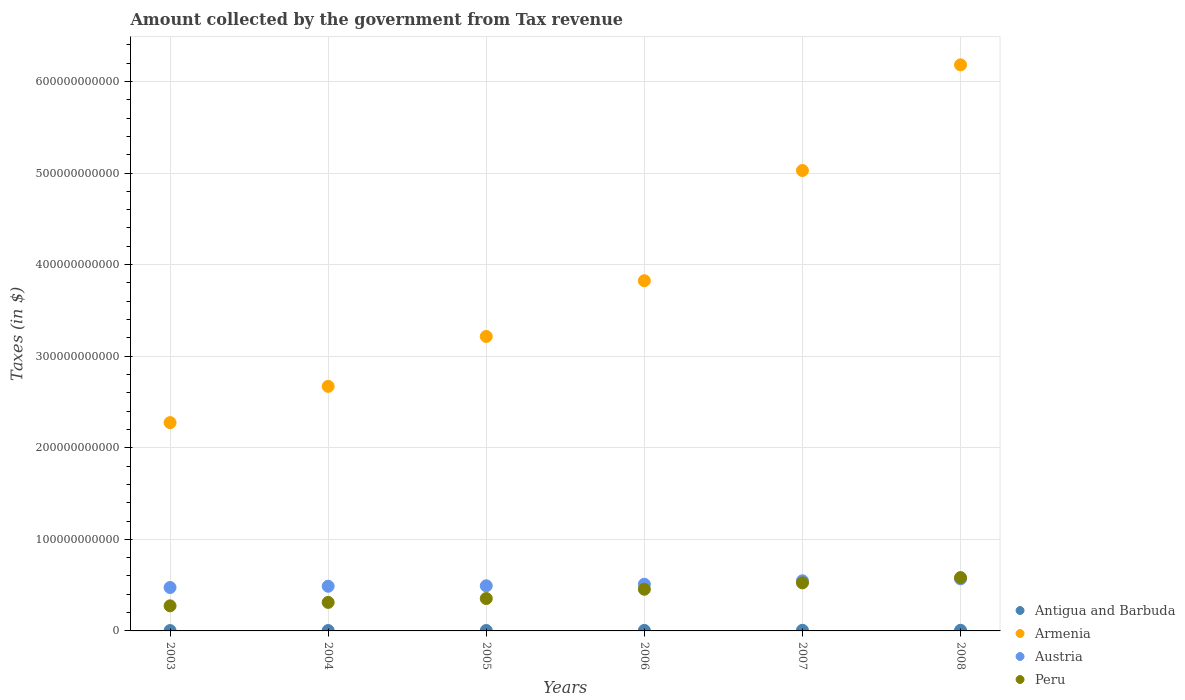How many different coloured dotlines are there?
Give a very brief answer. 4. What is the amount collected by the government from tax revenue in Peru in 2007?
Offer a terse response. 5.25e+1. Across all years, what is the maximum amount collected by the government from tax revenue in Austria?
Offer a terse response. 5.69e+1. Across all years, what is the minimum amount collected by the government from tax revenue in Peru?
Your answer should be compact. 2.74e+1. What is the total amount collected by the government from tax revenue in Austria in the graph?
Provide a short and direct response. 3.08e+11. What is the difference between the amount collected by the government from tax revenue in Armenia in 2004 and that in 2007?
Provide a succinct answer. -2.36e+11. What is the difference between the amount collected by the government from tax revenue in Peru in 2006 and the amount collected by the government from tax revenue in Antigua and Barbuda in 2004?
Your response must be concise. 4.51e+1. What is the average amount collected by the government from tax revenue in Antigua and Barbuda per year?
Offer a terse response. 5.36e+08. In the year 2005, what is the difference between the amount collected by the government from tax revenue in Austria and amount collected by the government from tax revenue in Armenia?
Give a very brief answer. -2.72e+11. What is the ratio of the amount collected by the government from tax revenue in Austria in 2003 to that in 2007?
Offer a terse response. 0.87. What is the difference between the highest and the second highest amount collected by the government from tax revenue in Antigua and Barbuda?
Your answer should be compact. 1.50e+06. What is the difference between the highest and the lowest amount collected by the government from tax revenue in Antigua and Barbuda?
Your answer should be compact. 3.09e+08. Is the sum of the amount collected by the government from tax revenue in Antigua and Barbuda in 2004 and 2005 greater than the maximum amount collected by the government from tax revenue in Peru across all years?
Offer a very short reply. No. Does the amount collected by the government from tax revenue in Antigua and Barbuda monotonically increase over the years?
Your answer should be compact. Yes. Is the amount collected by the government from tax revenue in Peru strictly greater than the amount collected by the government from tax revenue in Antigua and Barbuda over the years?
Make the answer very short. Yes. What is the difference between two consecutive major ticks on the Y-axis?
Keep it short and to the point. 1.00e+11. Are the values on the major ticks of Y-axis written in scientific E-notation?
Ensure brevity in your answer.  No. Does the graph contain any zero values?
Keep it short and to the point. No. Does the graph contain grids?
Give a very brief answer. Yes. How many legend labels are there?
Keep it short and to the point. 4. How are the legend labels stacked?
Your answer should be very brief. Vertical. What is the title of the graph?
Provide a succinct answer. Amount collected by the government from Tax revenue. What is the label or title of the X-axis?
Provide a short and direct response. Years. What is the label or title of the Y-axis?
Make the answer very short. Taxes (in $). What is the Taxes (in $) in Antigua and Barbuda in 2003?
Offer a very short reply. 3.83e+08. What is the Taxes (in $) of Armenia in 2003?
Provide a short and direct response. 2.27e+11. What is the Taxes (in $) in Austria in 2003?
Your response must be concise. 4.74e+1. What is the Taxes (in $) in Peru in 2003?
Keep it short and to the point. 2.74e+1. What is the Taxes (in $) of Antigua and Barbuda in 2004?
Give a very brief answer. 4.27e+08. What is the Taxes (in $) in Armenia in 2004?
Ensure brevity in your answer.  2.67e+11. What is the Taxes (in $) in Austria in 2004?
Make the answer very short. 4.88e+1. What is the Taxes (in $) of Peru in 2004?
Give a very brief answer. 3.11e+1. What is the Taxes (in $) in Antigua and Barbuda in 2005?
Keep it short and to the point. 4.55e+08. What is the Taxes (in $) of Armenia in 2005?
Make the answer very short. 3.22e+11. What is the Taxes (in $) of Austria in 2005?
Offer a very short reply. 4.93e+1. What is the Taxes (in $) of Peru in 2005?
Give a very brief answer. 3.54e+1. What is the Taxes (in $) in Antigua and Barbuda in 2006?
Give a very brief answer. 5.68e+08. What is the Taxes (in $) of Armenia in 2006?
Offer a terse response. 3.82e+11. What is the Taxes (in $) in Austria in 2006?
Ensure brevity in your answer.  5.10e+1. What is the Taxes (in $) in Peru in 2006?
Your answer should be very brief. 4.55e+1. What is the Taxes (in $) of Antigua and Barbuda in 2007?
Make the answer very short. 6.91e+08. What is the Taxes (in $) of Armenia in 2007?
Provide a short and direct response. 5.03e+11. What is the Taxes (in $) of Austria in 2007?
Your answer should be compact. 5.47e+1. What is the Taxes (in $) in Peru in 2007?
Make the answer very short. 5.25e+1. What is the Taxes (in $) of Antigua and Barbuda in 2008?
Ensure brevity in your answer.  6.92e+08. What is the Taxes (in $) in Armenia in 2008?
Offer a terse response. 6.18e+11. What is the Taxes (in $) of Austria in 2008?
Provide a succinct answer. 5.69e+1. What is the Taxes (in $) of Peru in 2008?
Offer a very short reply. 5.82e+1. Across all years, what is the maximum Taxes (in $) of Antigua and Barbuda?
Give a very brief answer. 6.92e+08. Across all years, what is the maximum Taxes (in $) in Armenia?
Provide a short and direct response. 6.18e+11. Across all years, what is the maximum Taxes (in $) in Austria?
Provide a succinct answer. 5.69e+1. Across all years, what is the maximum Taxes (in $) of Peru?
Provide a short and direct response. 5.82e+1. Across all years, what is the minimum Taxes (in $) of Antigua and Barbuda?
Your answer should be very brief. 3.83e+08. Across all years, what is the minimum Taxes (in $) of Armenia?
Offer a terse response. 2.27e+11. Across all years, what is the minimum Taxes (in $) of Austria?
Your response must be concise. 4.74e+1. Across all years, what is the minimum Taxes (in $) of Peru?
Keep it short and to the point. 2.74e+1. What is the total Taxes (in $) of Antigua and Barbuda in the graph?
Offer a very short reply. 3.22e+09. What is the total Taxes (in $) in Armenia in the graph?
Give a very brief answer. 2.32e+12. What is the total Taxes (in $) in Austria in the graph?
Your answer should be very brief. 3.08e+11. What is the total Taxes (in $) in Peru in the graph?
Provide a short and direct response. 2.50e+11. What is the difference between the Taxes (in $) in Antigua and Barbuda in 2003 and that in 2004?
Offer a terse response. -4.40e+07. What is the difference between the Taxes (in $) of Armenia in 2003 and that in 2004?
Provide a succinct answer. -3.96e+1. What is the difference between the Taxes (in $) in Austria in 2003 and that in 2004?
Keep it short and to the point. -1.38e+09. What is the difference between the Taxes (in $) in Peru in 2003 and that in 2004?
Your answer should be compact. -3.74e+09. What is the difference between the Taxes (in $) in Antigua and Barbuda in 2003 and that in 2005?
Your response must be concise. -7.18e+07. What is the difference between the Taxes (in $) in Armenia in 2003 and that in 2005?
Offer a terse response. -9.41e+1. What is the difference between the Taxes (in $) of Austria in 2003 and that in 2005?
Ensure brevity in your answer.  -1.86e+09. What is the difference between the Taxes (in $) in Peru in 2003 and that in 2005?
Offer a very short reply. -7.96e+09. What is the difference between the Taxes (in $) of Antigua and Barbuda in 2003 and that in 2006?
Provide a short and direct response. -1.84e+08. What is the difference between the Taxes (in $) in Armenia in 2003 and that in 2006?
Keep it short and to the point. -1.55e+11. What is the difference between the Taxes (in $) in Austria in 2003 and that in 2006?
Offer a terse response. -3.57e+09. What is the difference between the Taxes (in $) in Peru in 2003 and that in 2006?
Keep it short and to the point. -1.81e+1. What is the difference between the Taxes (in $) in Antigua and Barbuda in 2003 and that in 2007?
Keep it short and to the point. -3.08e+08. What is the difference between the Taxes (in $) in Armenia in 2003 and that in 2007?
Offer a very short reply. -2.75e+11. What is the difference between the Taxes (in $) in Austria in 2003 and that in 2007?
Provide a short and direct response. -7.33e+09. What is the difference between the Taxes (in $) of Peru in 2003 and that in 2007?
Your answer should be very brief. -2.50e+1. What is the difference between the Taxes (in $) in Antigua and Barbuda in 2003 and that in 2008?
Make the answer very short. -3.09e+08. What is the difference between the Taxes (in $) of Armenia in 2003 and that in 2008?
Offer a terse response. -3.91e+11. What is the difference between the Taxes (in $) in Austria in 2003 and that in 2008?
Provide a short and direct response. -9.44e+09. What is the difference between the Taxes (in $) of Peru in 2003 and that in 2008?
Provide a succinct answer. -3.08e+1. What is the difference between the Taxes (in $) of Antigua and Barbuda in 2004 and that in 2005?
Provide a succinct answer. -2.78e+07. What is the difference between the Taxes (in $) in Armenia in 2004 and that in 2005?
Your response must be concise. -5.45e+1. What is the difference between the Taxes (in $) in Austria in 2004 and that in 2005?
Make the answer very short. -4.75e+08. What is the difference between the Taxes (in $) in Peru in 2004 and that in 2005?
Offer a very short reply. -4.22e+09. What is the difference between the Taxes (in $) of Antigua and Barbuda in 2004 and that in 2006?
Ensure brevity in your answer.  -1.40e+08. What is the difference between the Taxes (in $) in Armenia in 2004 and that in 2006?
Your response must be concise. -1.15e+11. What is the difference between the Taxes (in $) in Austria in 2004 and that in 2006?
Your response must be concise. -2.19e+09. What is the difference between the Taxes (in $) of Peru in 2004 and that in 2006?
Provide a short and direct response. -1.43e+1. What is the difference between the Taxes (in $) in Antigua and Barbuda in 2004 and that in 2007?
Ensure brevity in your answer.  -2.64e+08. What is the difference between the Taxes (in $) of Armenia in 2004 and that in 2007?
Keep it short and to the point. -2.36e+11. What is the difference between the Taxes (in $) in Austria in 2004 and that in 2007?
Keep it short and to the point. -5.95e+09. What is the difference between the Taxes (in $) in Peru in 2004 and that in 2007?
Make the answer very short. -2.13e+1. What is the difference between the Taxes (in $) in Antigua and Barbuda in 2004 and that in 2008?
Provide a succinct answer. -2.65e+08. What is the difference between the Taxes (in $) in Armenia in 2004 and that in 2008?
Ensure brevity in your answer.  -3.51e+11. What is the difference between the Taxes (in $) in Austria in 2004 and that in 2008?
Your answer should be compact. -8.06e+09. What is the difference between the Taxes (in $) in Peru in 2004 and that in 2008?
Offer a very short reply. -2.71e+1. What is the difference between the Taxes (in $) of Antigua and Barbuda in 2005 and that in 2006?
Offer a terse response. -1.13e+08. What is the difference between the Taxes (in $) in Armenia in 2005 and that in 2006?
Offer a very short reply. -6.09e+1. What is the difference between the Taxes (in $) of Austria in 2005 and that in 2006?
Ensure brevity in your answer.  -1.71e+09. What is the difference between the Taxes (in $) of Peru in 2005 and that in 2006?
Make the answer very short. -1.01e+1. What is the difference between the Taxes (in $) of Antigua and Barbuda in 2005 and that in 2007?
Offer a terse response. -2.36e+08. What is the difference between the Taxes (in $) of Armenia in 2005 and that in 2007?
Keep it short and to the point. -1.81e+11. What is the difference between the Taxes (in $) of Austria in 2005 and that in 2007?
Provide a short and direct response. -5.47e+09. What is the difference between the Taxes (in $) of Peru in 2005 and that in 2007?
Make the answer very short. -1.71e+1. What is the difference between the Taxes (in $) of Antigua and Barbuda in 2005 and that in 2008?
Provide a short and direct response. -2.37e+08. What is the difference between the Taxes (in $) of Armenia in 2005 and that in 2008?
Make the answer very short. -2.97e+11. What is the difference between the Taxes (in $) of Austria in 2005 and that in 2008?
Ensure brevity in your answer.  -7.59e+09. What is the difference between the Taxes (in $) of Peru in 2005 and that in 2008?
Keep it short and to the point. -2.29e+1. What is the difference between the Taxes (in $) of Antigua and Barbuda in 2006 and that in 2007?
Your response must be concise. -1.23e+08. What is the difference between the Taxes (in $) in Armenia in 2006 and that in 2007?
Your answer should be compact. -1.20e+11. What is the difference between the Taxes (in $) in Austria in 2006 and that in 2007?
Ensure brevity in your answer.  -3.76e+09. What is the difference between the Taxes (in $) in Peru in 2006 and that in 2007?
Ensure brevity in your answer.  -6.97e+09. What is the difference between the Taxes (in $) in Antigua and Barbuda in 2006 and that in 2008?
Offer a very short reply. -1.25e+08. What is the difference between the Taxes (in $) in Armenia in 2006 and that in 2008?
Give a very brief answer. -2.36e+11. What is the difference between the Taxes (in $) in Austria in 2006 and that in 2008?
Provide a succinct answer. -5.88e+09. What is the difference between the Taxes (in $) in Peru in 2006 and that in 2008?
Your answer should be very brief. -1.28e+1. What is the difference between the Taxes (in $) in Antigua and Barbuda in 2007 and that in 2008?
Ensure brevity in your answer.  -1.50e+06. What is the difference between the Taxes (in $) of Armenia in 2007 and that in 2008?
Make the answer very short. -1.15e+11. What is the difference between the Taxes (in $) in Austria in 2007 and that in 2008?
Give a very brief answer. -2.12e+09. What is the difference between the Taxes (in $) of Peru in 2007 and that in 2008?
Your answer should be very brief. -5.79e+09. What is the difference between the Taxes (in $) of Antigua and Barbuda in 2003 and the Taxes (in $) of Armenia in 2004?
Provide a short and direct response. -2.67e+11. What is the difference between the Taxes (in $) of Antigua and Barbuda in 2003 and the Taxes (in $) of Austria in 2004?
Your answer should be compact. -4.84e+1. What is the difference between the Taxes (in $) in Antigua and Barbuda in 2003 and the Taxes (in $) in Peru in 2004?
Offer a terse response. -3.08e+1. What is the difference between the Taxes (in $) in Armenia in 2003 and the Taxes (in $) in Austria in 2004?
Offer a very short reply. 1.79e+11. What is the difference between the Taxes (in $) of Armenia in 2003 and the Taxes (in $) of Peru in 2004?
Give a very brief answer. 1.96e+11. What is the difference between the Taxes (in $) in Austria in 2003 and the Taxes (in $) in Peru in 2004?
Keep it short and to the point. 1.63e+1. What is the difference between the Taxes (in $) of Antigua and Barbuda in 2003 and the Taxes (in $) of Armenia in 2005?
Provide a short and direct response. -3.21e+11. What is the difference between the Taxes (in $) of Antigua and Barbuda in 2003 and the Taxes (in $) of Austria in 2005?
Your answer should be compact. -4.89e+1. What is the difference between the Taxes (in $) in Antigua and Barbuda in 2003 and the Taxes (in $) in Peru in 2005?
Your answer should be compact. -3.50e+1. What is the difference between the Taxes (in $) of Armenia in 2003 and the Taxes (in $) of Austria in 2005?
Ensure brevity in your answer.  1.78e+11. What is the difference between the Taxes (in $) in Armenia in 2003 and the Taxes (in $) in Peru in 2005?
Your response must be concise. 1.92e+11. What is the difference between the Taxes (in $) of Austria in 2003 and the Taxes (in $) of Peru in 2005?
Offer a very short reply. 1.20e+1. What is the difference between the Taxes (in $) of Antigua and Barbuda in 2003 and the Taxes (in $) of Armenia in 2006?
Offer a terse response. -3.82e+11. What is the difference between the Taxes (in $) in Antigua and Barbuda in 2003 and the Taxes (in $) in Austria in 2006?
Your answer should be compact. -5.06e+1. What is the difference between the Taxes (in $) in Antigua and Barbuda in 2003 and the Taxes (in $) in Peru in 2006?
Offer a terse response. -4.51e+1. What is the difference between the Taxes (in $) of Armenia in 2003 and the Taxes (in $) of Austria in 2006?
Your answer should be very brief. 1.76e+11. What is the difference between the Taxes (in $) in Armenia in 2003 and the Taxes (in $) in Peru in 2006?
Your answer should be compact. 1.82e+11. What is the difference between the Taxes (in $) of Austria in 2003 and the Taxes (in $) of Peru in 2006?
Offer a very short reply. 1.93e+09. What is the difference between the Taxes (in $) of Antigua and Barbuda in 2003 and the Taxes (in $) of Armenia in 2007?
Your response must be concise. -5.02e+11. What is the difference between the Taxes (in $) in Antigua and Barbuda in 2003 and the Taxes (in $) in Austria in 2007?
Make the answer very short. -5.44e+1. What is the difference between the Taxes (in $) of Antigua and Barbuda in 2003 and the Taxes (in $) of Peru in 2007?
Offer a very short reply. -5.21e+1. What is the difference between the Taxes (in $) of Armenia in 2003 and the Taxes (in $) of Austria in 2007?
Offer a terse response. 1.73e+11. What is the difference between the Taxes (in $) in Armenia in 2003 and the Taxes (in $) in Peru in 2007?
Provide a succinct answer. 1.75e+11. What is the difference between the Taxes (in $) in Austria in 2003 and the Taxes (in $) in Peru in 2007?
Keep it short and to the point. -5.04e+09. What is the difference between the Taxes (in $) of Antigua and Barbuda in 2003 and the Taxes (in $) of Armenia in 2008?
Provide a short and direct response. -6.18e+11. What is the difference between the Taxes (in $) of Antigua and Barbuda in 2003 and the Taxes (in $) of Austria in 2008?
Your response must be concise. -5.65e+1. What is the difference between the Taxes (in $) in Antigua and Barbuda in 2003 and the Taxes (in $) in Peru in 2008?
Your response must be concise. -5.79e+1. What is the difference between the Taxes (in $) in Armenia in 2003 and the Taxes (in $) in Austria in 2008?
Make the answer very short. 1.71e+11. What is the difference between the Taxes (in $) of Armenia in 2003 and the Taxes (in $) of Peru in 2008?
Your answer should be compact. 1.69e+11. What is the difference between the Taxes (in $) of Austria in 2003 and the Taxes (in $) of Peru in 2008?
Your response must be concise. -1.08e+1. What is the difference between the Taxes (in $) in Antigua and Barbuda in 2004 and the Taxes (in $) in Armenia in 2005?
Give a very brief answer. -3.21e+11. What is the difference between the Taxes (in $) of Antigua and Barbuda in 2004 and the Taxes (in $) of Austria in 2005?
Keep it short and to the point. -4.88e+1. What is the difference between the Taxes (in $) in Antigua and Barbuda in 2004 and the Taxes (in $) in Peru in 2005?
Provide a short and direct response. -3.49e+1. What is the difference between the Taxes (in $) in Armenia in 2004 and the Taxes (in $) in Austria in 2005?
Your response must be concise. 2.18e+11. What is the difference between the Taxes (in $) of Armenia in 2004 and the Taxes (in $) of Peru in 2005?
Provide a succinct answer. 2.32e+11. What is the difference between the Taxes (in $) in Austria in 2004 and the Taxes (in $) in Peru in 2005?
Keep it short and to the point. 1.34e+1. What is the difference between the Taxes (in $) in Antigua and Barbuda in 2004 and the Taxes (in $) in Armenia in 2006?
Your answer should be very brief. -3.82e+11. What is the difference between the Taxes (in $) of Antigua and Barbuda in 2004 and the Taxes (in $) of Austria in 2006?
Ensure brevity in your answer.  -5.06e+1. What is the difference between the Taxes (in $) of Antigua and Barbuda in 2004 and the Taxes (in $) of Peru in 2006?
Provide a succinct answer. -4.51e+1. What is the difference between the Taxes (in $) of Armenia in 2004 and the Taxes (in $) of Austria in 2006?
Make the answer very short. 2.16e+11. What is the difference between the Taxes (in $) of Armenia in 2004 and the Taxes (in $) of Peru in 2006?
Ensure brevity in your answer.  2.22e+11. What is the difference between the Taxes (in $) in Austria in 2004 and the Taxes (in $) in Peru in 2006?
Provide a short and direct response. 3.31e+09. What is the difference between the Taxes (in $) of Antigua and Barbuda in 2004 and the Taxes (in $) of Armenia in 2007?
Ensure brevity in your answer.  -5.02e+11. What is the difference between the Taxes (in $) in Antigua and Barbuda in 2004 and the Taxes (in $) in Austria in 2007?
Provide a short and direct response. -5.43e+1. What is the difference between the Taxes (in $) of Antigua and Barbuda in 2004 and the Taxes (in $) of Peru in 2007?
Offer a very short reply. -5.20e+1. What is the difference between the Taxes (in $) in Armenia in 2004 and the Taxes (in $) in Austria in 2007?
Provide a short and direct response. 2.12e+11. What is the difference between the Taxes (in $) in Armenia in 2004 and the Taxes (in $) in Peru in 2007?
Offer a terse response. 2.15e+11. What is the difference between the Taxes (in $) in Austria in 2004 and the Taxes (in $) in Peru in 2007?
Your answer should be compact. -3.66e+09. What is the difference between the Taxes (in $) of Antigua and Barbuda in 2004 and the Taxes (in $) of Armenia in 2008?
Offer a terse response. -6.18e+11. What is the difference between the Taxes (in $) in Antigua and Barbuda in 2004 and the Taxes (in $) in Austria in 2008?
Your response must be concise. -5.64e+1. What is the difference between the Taxes (in $) of Antigua and Barbuda in 2004 and the Taxes (in $) of Peru in 2008?
Ensure brevity in your answer.  -5.78e+1. What is the difference between the Taxes (in $) in Armenia in 2004 and the Taxes (in $) in Austria in 2008?
Your answer should be compact. 2.10e+11. What is the difference between the Taxes (in $) in Armenia in 2004 and the Taxes (in $) in Peru in 2008?
Provide a succinct answer. 2.09e+11. What is the difference between the Taxes (in $) in Austria in 2004 and the Taxes (in $) in Peru in 2008?
Ensure brevity in your answer.  -9.45e+09. What is the difference between the Taxes (in $) in Antigua and Barbuda in 2005 and the Taxes (in $) in Armenia in 2006?
Offer a very short reply. -3.82e+11. What is the difference between the Taxes (in $) of Antigua and Barbuda in 2005 and the Taxes (in $) of Austria in 2006?
Offer a very short reply. -5.05e+1. What is the difference between the Taxes (in $) of Antigua and Barbuda in 2005 and the Taxes (in $) of Peru in 2006?
Give a very brief answer. -4.50e+1. What is the difference between the Taxes (in $) in Armenia in 2005 and the Taxes (in $) in Austria in 2006?
Keep it short and to the point. 2.71e+11. What is the difference between the Taxes (in $) of Armenia in 2005 and the Taxes (in $) of Peru in 2006?
Provide a short and direct response. 2.76e+11. What is the difference between the Taxes (in $) of Austria in 2005 and the Taxes (in $) of Peru in 2006?
Provide a short and direct response. 3.78e+09. What is the difference between the Taxes (in $) in Antigua and Barbuda in 2005 and the Taxes (in $) in Armenia in 2007?
Ensure brevity in your answer.  -5.02e+11. What is the difference between the Taxes (in $) in Antigua and Barbuda in 2005 and the Taxes (in $) in Austria in 2007?
Offer a very short reply. -5.43e+1. What is the difference between the Taxes (in $) in Antigua and Barbuda in 2005 and the Taxes (in $) in Peru in 2007?
Your answer should be compact. -5.20e+1. What is the difference between the Taxes (in $) of Armenia in 2005 and the Taxes (in $) of Austria in 2007?
Give a very brief answer. 2.67e+11. What is the difference between the Taxes (in $) in Armenia in 2005 and the Taxes (in $) in Peru in 2007?
Ensure brevity in your answer.  2.69e+11. What is the difference between the Taxes (in $) in Austria in 2005 and the Taxes (in $) in Peru in 2007?
Make the answer very short. -3.19e+09. What is the difference between the Taxes (in $) of Antigua and Barbuda in 2005 and the Taxes (in $) of Armenia in 2008?
Your response must be concise. -6.18e+11. What is the difference between the Taxes (in $) in Antigua and Barbuda in 2005 and the Taxes (in $) in Austria in 2008?
Offer a very short reply. -5.64e+1. What is the difference between the Taxes (in $) of Antigua and Barbuda in 2005 and the Taxes (in $) of Peru in 2008?
Your answer should be compact. -5.78e+1. What is the difference between the Taxes (in $) in Armenia in 2005 and the Taxes (in $) in Austria in 2008?
Provide a short and direct response. 2.65e+11. What is the difference between the Taxes (in $) in Armenia in 2005 and the Taxes (in $) in Peru in 2008?
Your answer should be compact. 2.63e+11. What is the difference between the Taxes (in $) of Austria in 2005 and the Taxes (in $) of Peru in 2008?
Make the answer very short. -8.97e+09. What is the difference between the Taxes (in $) in Antigua and Barbuda in 2006 and the Taxes (in $) in Armenia in 2007?
Your answer should be compact. -5.02e+11. What is the difference between the Taxes (in $) in Antigua and Barbuda in 2006 and the Taxes (in $) in Austria in 2007?
Offer a terse response. -5.42e+1. What is the difference between the Taxes (in $) in Antigua and Barbuda in 2006 and the Taxes (in $) in Peru in 2007?
Your answer should be very brief. -5.19e+1. What is the difference between the Taxes (in $) of Armenia in 2006 and the Taxes (in $) of Austria in 2007?
Make the answer very short. 3.28e+11. What is the difference between the Taxes (in $) in Armenia in 2006 and the Taxes (in $) in Peru in 2007?
Give a very brief answer. 3.30e+11. What is the difference between the Taxes (in $) in Austria in 2006 and the Taxes (in $) in Peru in 2007?
Your response must be concise. -1.48e+09. What is the difference between the Taxes (in $) in Antigua and Barbuda in 2006 and the Taxes (in $) in Armenia in 2008?
Offer a terse response. -6.18e+11. What is the difference between the Taxes (in $) in Antigua and Barbuda in 2006 and the Taxes (in $) in Austria in 2008?
Offer a terse response. -5.63e+1. What is the difference between the Taxes (in $) of Antigua and Barbuda in 2006 and the Taxes (in $) of Peru in 2008?
Keep it short and to the point. -5.77e+1. What is the difference between the Taxes (in $) in Armenia in 2006 and the Taxes (in $) in Austria in 2008?
Your response must be concise. 3.26e+11. What is the difference between the Taxes (in $) of Armenia in 2006 and the Taxes (in $) of Peru in 2008?
Provide a short and direct response. 3.24e+11. What is the difference between the Taxes (in $) of Austria in 2006 and the Taxes (in $) of Peru in 2008?
Your answer should be very brief. -7.26e+09. What is the difference between the Taxes (in $) in Antigua and Barbuda in 2007 and the Taxes (in $) in Armenia in 2008?
Provide a succinct answer. -6.17e+11. What is the difference between the Taxes (in $) of Antigua and Barbuda in 2007 and the Taxes (in $) of Austria in 2008?
Offer a very short reply. -5.62e+1. What is the difference between the Taxes (in $) in Antigua and Barbuda in 2007 and the Taxes (in $) in Peru in 2008?
Offer a terse response. -5.76e+1. What is the difference between the Taxes (in $) in Armenia in 2007 and the Taxes (in $) in Austria in 2008?
Your response must be concise. 4.46e+11. What is the difference between the Taxes (in $) of Armenia in 2007 and the Taxes (in $) of Peru in 2008?
Your answer should be very brief. 4.44e+11. What is the difference between the Taxes (in $) of Austria in 2007 and the Taxes (in $) of Peru in 2008?
Your response must be concise. -3.50e+09. What is the average Taxes (in $) of Antigua and Barbuda per year?
Make the answer very short. 5.36e+08. What is the average Taxes (in $) in Armenia per year?
Offer a terse response. 3.87e+11. What is the average Taxes (in $) of Austria per year?
Make the answer very short. 5.13e+1. What is the average Taxes (in $) in Peru per year?
Give a very brief answer. 4.17e+1. In the year 2003, what is the difference between the Taxes (in $) of Antigua and Barbuda and Taxes (in $) of Armenia?
Offer a terse response. -2.27e+11. In the year 2003, what is the difference between the Taxes (in $) of Antigua and Barbuda and Taxes (in $) of Austria?
Offer a very short reply. -4.70e+1. In the year 2003, what is the difference between the Taxes (in $) of Antigua and Barbuda and Taxes (in $) of Peru?
Keep it short and to the point. -2.70e+1. In the year 2003, what is the difference between the Taxes (in $) of Armenia and Taxes (in $) of Austria?
Offer a terse response. 1.80e+11. In the year 2003, what is the difference between the Taxes (in $) of Armenia and Taxes (in $) of Peru?
Your answer should be very brief. 2.00e+11. In the year 2003, what is the difference between the Taxes (in $) in Austria and Taxes (in $) in Peru?
Provide a succinct answer. 2.00e+1. In the year 2004, what is the difference between the Taxes (in $) in Antigua and Barbuda and Taxes (in $) in Armenia?
Your answer should be very brief. -2.67e+11. In the year 2004, what is the difference between the Taxes (in $) in Antigua and Barbuda and Taxes (in $) in Austria?
Give a very brief answer. -4.84e+1. In the year 2004, what is the difference between the Taxes (in $) of Antigua and Barbuda and Taxes (in $) of Peru?
Your answer should be compact. -3.07e+1. In the year 2004, what is the difference between the Taxes (in $) in Armenia and Taxes (in $) in Austria?
Make the answer very short. 2.18e+11. In the year 2004, what is the difference between the Taxes (in $) of Armenia and Taxes (in $) of Peru?
Your answer should be compact. 2.36e+11. In the year 2004, what is the difference between the Taxes (in $) of Austria and Taxes (in $) of Peru?
Your response must be concise. 1.76e+1. In the year 2005, what is the difference between the Taxes (in $) of Antigua and Barbuda and Taxes (in $) of Armenia?
Offer a terse response. -3.21e+11. In the year 2005, what is the difference between the Taxes (in $) of Antigua and Barbuda and Taxes (in $) of Austria?
Ensure brevity in your answer.  -4.88e+1. In the year 2005, what is the difference between the Taxes (in $) of Antigua and Barbuda and Taxes (in $) of Peru?
Your answer should be very brief. -3.49e+1. In the year 2005, what is the difference between the Taxes (in $) in Armenia and Taxes (in $) in Austria?
Make the answer very short. 2.72e+11. In the year 2005, what is the difference between the Taxes (in $) in Armenia and Taxes (in $) in Peru?
Your answer should be very brief. 2.86e+11. In the year 2005, what is the difference between the Taxes (in $) in Austria and Taxes (in $) in Peru?
Provide a short and direct response. 1.39e+1. In the year 2006, what is the difference between the Taxes (in $) in Antigua and Barbuda and Taxes (in $) in Armenia?
Offer a very short reply. -3.82e+11. In the year 2006, what is the difference between the Taxes (in $) of Antigua and Barbuda and Taxes (in $) of Austria?
Your response must be concise. -5.04e+1. In the year 2006, what is the difference between the Taxes (in $) in Antigua and Barbuda and Taxes (in $) in Peru?
Provide a succinct answer. -4.49e+1. In the year 2006, what is the difference between the Taxes (in $) in Armenia and Taxes (in $) in Austria?
Your answer should be very brief. 3.31e+11. In the year 2006, what is the difference between the Taxes (in $) in Armenia and Taxes (in $) in Peru?
Offer a very short reply. 3.37e+11. In the year 2006, what is the difference between the Taxes (in $) in Austria and Taxes (in $) in Peru?
Make the answer very short. 5.49e+09. In the year 2007, what is the difference between the Taxes (in $) in Antigua and Barbuda and Taxes (in $) in Armenia?
Provide a short and direct response. -5.02e+11. In the year 2007, what is the difference between the Taxes (in $) of Antigua and Barbuda and Taxes (in $) of Austria?
Provide a succinct answer. -5.40e+1. In the year 2007, what is the difference between the Taxes (in $) of Antigua and Barbuda and Taxes (in $) of Peru?
Your response must be concise. -5.18e+1. In the year 2007, what is the difference between the Taxes (in $) of Armenia and Taxes (in $) of Austria?
Offer a very short reply. 4.48e+11. In the year 2007, what is the difference between the Taxes (in $) of Armenia and Taxes (in $) of Peru?
Provide a succinct answer. 4.50e+11. In the year 2007, what is the difference between the Taxes (in $) of Austria and Taxes (in $) of Peru?
Your answer should be very brief. 2.29e+09. In the year 2008, what is the difference between the Taxes (in $) in Antigua and Barbuda and Taxes (in $) in Armenia?
Make the answer very short. -6.17e+11. In the year 2008, what is the difference between the Taxes (in $) in Antigua and Barbuda and Taxes (in $) in Austria?
Provide a succinct answer. -5.62e+1. In the year 2008, what is the difference between the Taxes (in $) of Antigua and Barbuda and Taxes (in $) of Peru?
Offer a terse response. -5.75e+1. In the year 2008, what is the difference between the Taxes (in $) in Armenia and Taxes (in $) in Austria?
Ensure brevity in your answer.  5.61e+11. In the year 2008, what is the difference between the Taxes (in $) of Armenia and Taxes (in $) of Peru?
Ensure brevity in your answer.  5.60e+11. In the year 2008, what is the difference between the Taxes (in $) in Austria and Taxes (in $) in Peru?
Your answer should be compact. -1.39e+09. What is the ratio of the Taxes (in $) in Antigua and Barbuda in 2003 to that in 2004?
Make the answer very short. 0.9. What is the ratio of the Taxes (in $) in Armenia in 2003 to that in 2004?
Provide a short and direct response. 0.85. What is the ratio of the Taxes (in $) in Austria in 2003 to that in 2004?
Offer a terse response. 0.97. What is the ratio of the Taxes (in $) in Peru in 2003 to that in 2004?
Keep it short and to the point. 0.88. What is the ratio of the Taxes (in $) of Antigua and Barbuda in 2003 to that in 2005?
Give a very brief answer. 0.84. What is the ratio of the Taxes (in $) of Armenia in 2003 to that in 2005?
Provide a short and direct response. 0.71. What is the ratio of the Taxes (in $) in Austria in 2003 to that in 2005?
Keep it short and to the point. 0.96. What is the ratio of the Taxes (in $) in Peru in 2003 to that in 2005?
Provide a succinct answer. 0.77. What is the ratio of the Taxes (in $) of Antigua and Barbuda in 2003 to that in 2006?
Make the answer very short. 0.68. What is the ratio of the Taxes (in $) of Armenia in 2003 to that in 2006?
Offer a very short reply. 0.59. What is the ratio of the Taxes (in $) in Austria in 2003 to that in 2006?
Provide a short and direct response. 0.93. What is the ratio of the Taxes (in $) in Peru in 2003 to that in 2006?
Provide a short and direct response. 0.6. What is the ratio of the Taxes (in $) of Antigua and Barbuda in 2003 to that in 2007?
Your answer should be compact. 0.55. What is the ratio of the Taxes (in $) of Armenia in 2003 to that in 2007?
Your answer should be very brief. 0.45. What is the ratio of the Taxes (in $) of Austria in 2003 to that in 2007?
Provide a short and direct response. 0.87. What is the ratio of the Taxes (in $) of Peru in 2003 to that in 2007?
Make the answer very short. 0.52. What is the ratio of the Taxes (in $) of Antigua and Barbuda in 2003 to that in 2008?
Offer a terse response. 0.55. What is the ratio of the Taxes (in $) of Armenia in 2003 to that in 2008?
Make the answer very short. 0.37. What is the ratio of the Taxes (in $) of Austria in 2003 to that in 2008?
Provide a succinct answer. 0.83. What is the ratio of the Taxes (in $) in Peru in 2003 to that in 2008?
Provide a succinct answer. 0.47. What is the ratio of the Taxes (in $) of Antigua and Barbuda in 2004 to that in 2005?
Offer a very short reply. 0.94. What is the ratio of the Taxes (in $) of Armenia in 2004 to that in 2005?
Ensure brevity in your answer.  0.83. What is the ratio of the Taxes (in $) in Austria in 2004 to that in 2005?
Provide a succinct answer. 0.99. What is the ratio of the Taxes (in $) of Peru in 2004 to that in 2005?
Offer a very short reply. 0.88. What is the ratio of the Taxes (in $) of Antigua and Barbuda in 2004 to that in 2006?
Make the answer very short. 0.75. What is the ratio of the Taxes (in $) in Armenia in 2004 to that in 2006?
Provide a short and direct response. 0.7. What is the ratio of the Taxes (in $) in Austria in 2004 to that in 2006?
Ensure brevity in your answer.  0.96. What is the ratio of the Taxes (in $) of Peru in 2004 to that in 2006?
Provide a short and direct response. 0.68. What is the ratio of the Taxes (in $) of Antigua and Barbuda in 2004 to that in 2007?
Your response must be concise. 0.62. What is the ratio of the Taxes (in $) in Armenia in 2004 to that in 2007?
Provide a short and direct response. 0.53. What is the ratio of the Taxes (in $) in Austria in 2004 to that in 2007?
Provide a succinct answer. 0.89. What is the ratio of the Taxes (in $) in Peru in 2004 to that in 2007?
Keep it short and to the point. 0.59. What is the ratio of the Taxes (in $) of Antigua and Barbuda in 2004 to that in 2008?
Your answer should be very brief. 0.62. What is the ratio of the Taxes (in $) in Armenia in 2004 to that in 2008?
Your response must be concise. 0.43. What is the ratio of the Taxes (in $) in Austria in 2004 to that in 2008?
Ensure brevity in your answer.  0.86. What is the ratio of the Taxes (in $) in Peru in 2004 to that in 2008?
Provide a succinct answer. 0.53. What is the ratio of the Taxes (in $) in Antigua and Barbuda in 2005 to that in 2006?
Ensure brevity in your answer.  0.8. What is the ratio of the Taxes (in $) in Armenia in 2005 to that in 2006?
Give a very brief answer. 0.84. What is the ratio of the Taxes (in $) in Austria in 2005 to that in 2006?
Your response must be concise. 0.97. What is the ratio of the Taxes (in $) of Peru in 2005 to that in 2006?
Provide a succinct answer. 0.78. What is the ratio of the Taxes (in $) of Antigua and Barbuda in 2005 to that in 2007?
Your response must be concise. 0.66. What is the ratio of the Taxes (in $) in Armenia in 2005 to that in 2007?
Your response must be concise. 0.64. What is the ratio of the Taxes (in $) of Peru in 2005 to that in 2007?
Keep it short and to the point. 0.67. What is the ratio of the Taxes (in $) of Antigua and Barbuda in 2005 to that in 2008?
Offer a very short reply. 0.66. What is the ratio of the Taxes (in $) in Armenia in 2005 to that in 2008?
Give a very brief answer. 0.52. What is the ratio of the Taxes (in $) in Austria in 2005 to that in 2008?
Keep it short and to the point. 0.87. What is the ratio of the Taxes (in $) of Peru in 2005 to that in 2008?
Keep it short and to the point. 0.61. What is the ratio of the Taxes (in $) in Antigua and Barbuda in 2006 to that in 2007?
Keep it short and to the point. 0.82. What is the ratio of the Taxes (in $) in Armenia in 2006 to that in 2007?
Provide a short and direct response. 0.76. What is the ratio of the Taxes (in $) of Austria in 2006 to that in 2007?
Ensure brevity in your answer.  0.93. What is the ratio of the Taxes (in $) of Peru in 2006 to that in 2007?
Make the answer very short. 0.87. What is the ratio of the Taxes (in $) of Antigua and Barbuda in 2006 to that in 2008?
Your answer should be very brief. 0.82. What is the ratio of the Taxes (in $) of Armenia in 2006 to that in 2008?
Keep it short and to the point. 0.62. What is the ratio of the Taxes (in $) of Austria in 2006 to that in 2008?
Give a very brief answer. 0.9. What is the ratio of the Taxes (in $) in Peru in 2006 to that in 2008?
Provide a succinct answer. 0.78. What is the ratio of the Taxes (in $) of Antigua and Barbuda in 2007 to that in 2008?
Offer a very short reply. 1. What is the ratio of the Taxes (in $) in Armenia in 2007 to that in 2008?
Keep it short and to the point. 0.81. What is the ratio of the Taxes (in $) in Austria in 2007 to that in 2008?
Offer a terse response. 0.96. What is the ratio of the Taxes (in $) in Peru in 2007 to that in 2008?
Offer a terse response. 0.9. What is the difference between the highest and the second highest Taxes (in $) of Antigua and Barbuda?
Offer a terse response. 1.50e+06. What is the difference between the highest and the second highest Taxes (in $) in Armenia?
Your answer should be compact. 1.15e+11. What is the difference between the highest and the second highest Taxes (in $) in Austria?
Give a very brief answer. 2.12e+09. What is the difference between the highest and the second highest Taxes (in $) of Peru?
Give a very brief answer. 5.79e+09. What is the difference between the highest and the lowest Taxes (in $) of Antigua and Barbuda?
Ensure brevity in your answer.  3.09e+08. What is the difference between the highest and the lowest Taxes (in $) in Armenia?
Your answer should be compact. 3.91e+11. What is the difference between the highest and the lowest Taxes (in $) in Austria?
Provide a short and direct response. 9.44e+09. What is the difference between the highest and the lowest Taxes (in $) in Peru?
Give a very brief answer. 3.08e+1. 